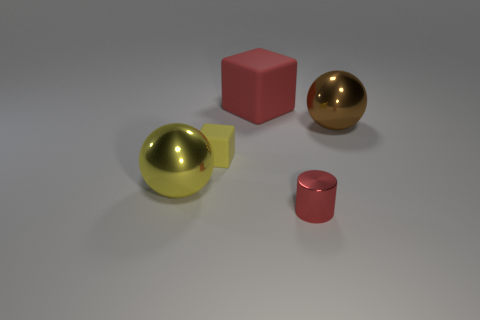What's the relationship of the objects in the image? The objects are arranged with clear space between them, each distinct in shape and finish. The two red blocks are similar in color but differ in size and position, while the spheres present a contrast not just in color but also in material properties, as one is shiny and likely metallic, and the other looks rubbery and matte. 